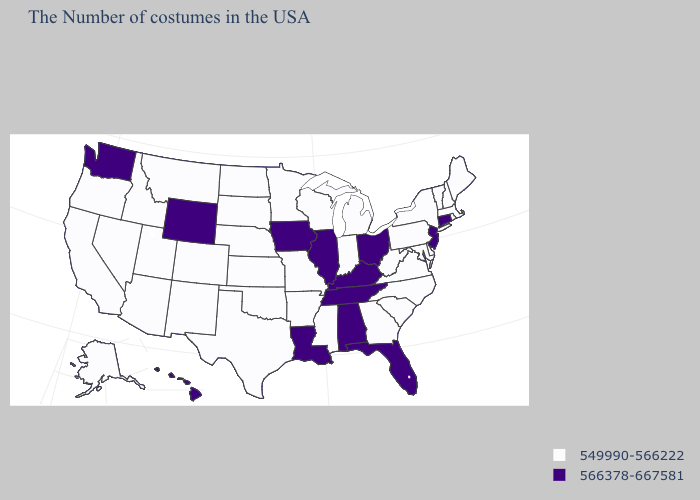What is the highest value in the USA?
Answer briefly. 566378-667581. What is the value of Montana?
Quick response, please. 549990-566222. Among the states that border Nebraska , which have the highest value?
Quick response, please. Iowa, Wyoming. Which states have the lowest value in the USA?
Be succinct. Maine, Massachusetts, Rhode Island, New Hampshire, Vermont, New York, Delaware, Maryland, Pennsylvania, Virginia, North Carolina, South Carolina, West Virginia, Georgia, Michigan, Indiana, Wisconsin, Mississippi, Missouri, Arkansas, Minnesota, Kansas, Nebraska, Oklahoma, Texas, South Dakota, North Dakota, Colorado, New Mexico, Utah, Montana, Arizona, Idaho, Nevada, California, Oregon, Alaska. Name the states that have a value in the range 566378-667581?
Write a very short answer. Connecticut, New Jersey, Ohio, Florida, Kentucky, Alabama, Tennessee, Illinois, Louisiana, Iowa, Wyoming, Washington, Hawaii. What is the value of Missouri?
Be succinct. 549990-566222. Does the map have missing data?
Quick response, please. No. Among the states that border Nebraska , does Wyoming have the highest value?
Be succinct. Yes. Does Ohio have the lowest value in the USA?
Quick response, please. No. Name the states that have a value in the range 549990-566222?
Keep it brief. Maine, Massachusetts, Rhode Island, New Hampshire, Vermont, New York, Delaware, Maryland, Pennsylvania, Virginia, North Carolina, South Carolina, West Virginia, Georgia, Michigan, Indiana, Wisconsin, Mississippi, Missouri, Arkansas, Minnesota, Kansas, Nebraska, Oklahoma, Texas, South Dakota, North Dakota, Colorado, New Mexico, Utah, Montana, Arizona, Idaho, Nevada, California, Oregon, Alaska. Name the states that have a value in the range 566378-667581?
Give a very brief answer. Connecticut, New Jersey, Ohio, Florida, Kentucky, Alabama, Tennessee, Illinois, Louisiana, Iowa, Wyoming, Washington, Hawaii. Which states have the lowest value in the MidWest?
Concise answer only. Michigan, Indiana, Wisconsin, Missouri, Minnesota, Kansas, Nebraska, South Dakota, North Dakota. Which states hav the highest value in the MidWest?
Give a very brief answer. Ohio, Illinois, Iowa. What is the lowest value in states that border Indiana?
Concise answer only. 549990-566222. Which states have the lowest value in the South?
Be succinct. Delaware, Maryland, Virginia, North Carolina, South Carolina, West Virginia, Georgia, Mississippi, Arkansas, Oklahoma, Texas. 